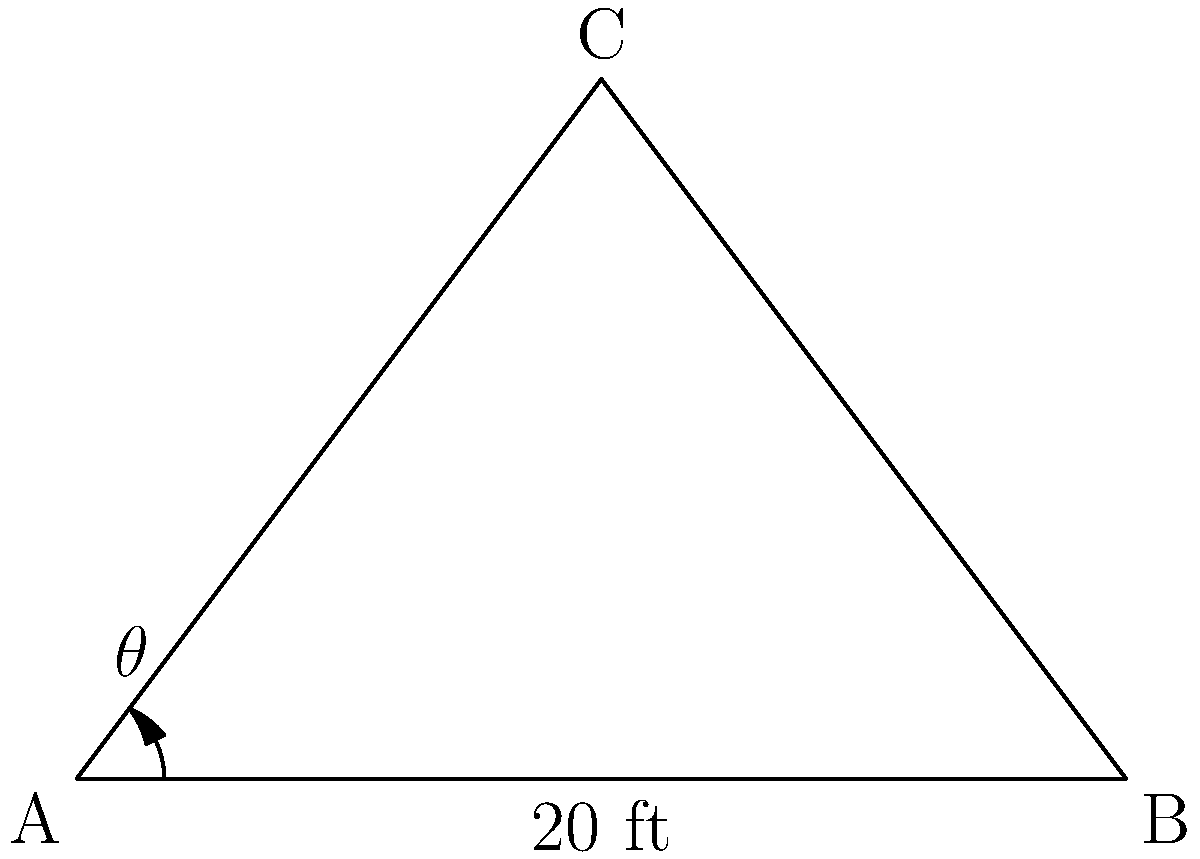As a small-business owner planning to install a billboard, you need to determine the optimal angle for visibility. The billboard will be 20 feet wide and needs to be visible from a distance of 30 feet directly in front of its center. What should be the angle $\theta$ (in degrees) between the billboard and the ground for optimal visibility? To solve this problem, we'll use trigonometry:

1. First, let's identify the triangle formed by the billboard and the viewing distance:
   - The base of the triangle is half the width of the billboard: 20/2 = 10 feet
   - The height of the triangle is the viewing distance: 30 feet

2. We can use the arctangent function to find the angle:
   $\theta = \arctan(\frac{\text{opposite}}{\text{adjacent}})$

3. Plugging in our values:
   $\theta = \arctan(\frac{30}{10})$

4. Simplify:
   $\theta = \arctan(3)$

5. Convert to degrees:
   $\theta = \arctan(3) \cdot \frac{180^{\circ}}{\pi}$

6. Calculate the final result:
   $\theta \approx 71.57^{\circ}$

7. Round to the nearest degree:
   $\theta \approx 72^{\circ}$

This angle will ensure that the billboard is perpendicular to the line of sight from the viewing distance, providing optimal visibility while complying with advertising regulations.
Answer: $72^{\circ}$ 